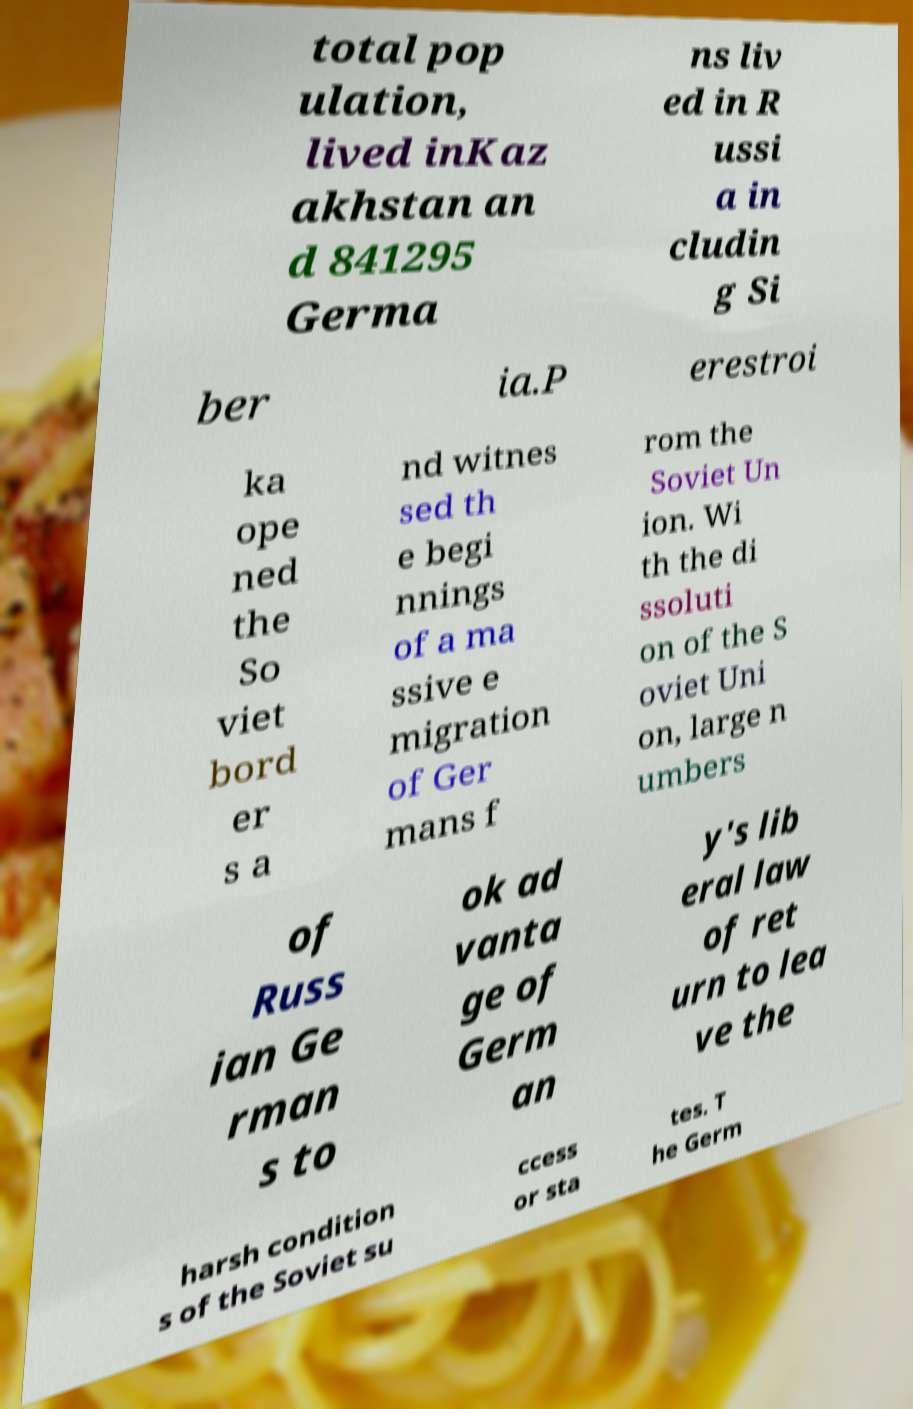Can you accurately transcribe the text from the provided image for me? total pop ulation, lived inKaz akhstan an d 841295 Germa ns liv ed in R ussi a in cludin g Si ber ia.P erestroi ka ope ned the So viet bord er s a nd witnes sed th e begi nnings of a ma ssive e migration of Ger mans f rom the Soviet Un ion. Wi th the di ssoluti on of the S oviet Uni on, large n umbers of Russ ian Ge rman s to ok ad vanta ge of Germ an y's lib eral law of ret urn to lea ve the harsh condition s of the Soviet su ccess or sta tes. T he Germ 